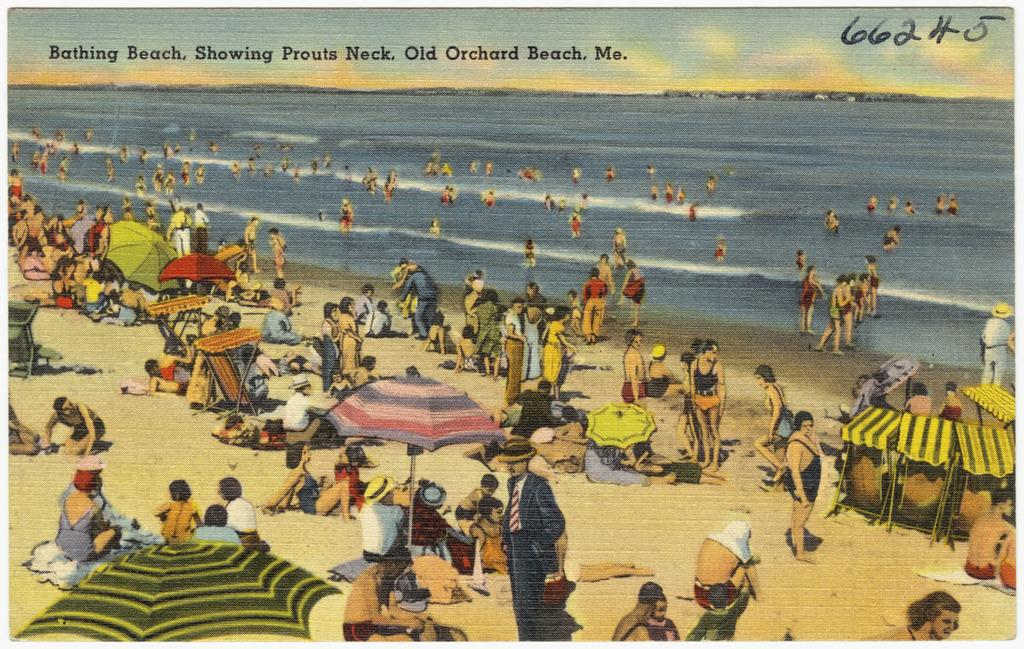What type of location is shown in the image? The image depicts a beach. Are there any people present at the beach? Yes, there are people present on the beach. What are some of the activities people are doing at the beach? Some people are laying down on the sand, while others are sitting under umbrellas or tents. What can be seen under the people's feet? The sand floor is visible. Can you see any yaks grazing on the beach in the image? No, there are no yaks present in the image. Is there a river flowing through the beach in the image? No, there is no river visible in the image; it is a beach setting. 